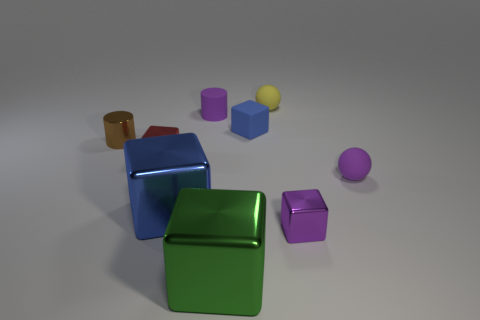Subtract all purple cubes. How many cubes are left? 4 Subtract all matte blocks. How many blocks are left? 4 Subtract all brown cubes. Subtract all red cylinders. How many cubes are left? 5 Subtract all spheres. How many objects are left? 7 Subtract all small red balls. Subtract all red cubes. How many objects are left? 8 Add 6 matte cylinders. How many matte cylinders are left? 7 Add 4 small red matte cylinders. How many small red matte cylinders exist? 4 Subtract 0 cyan cylinders. How many objects are left? 9 